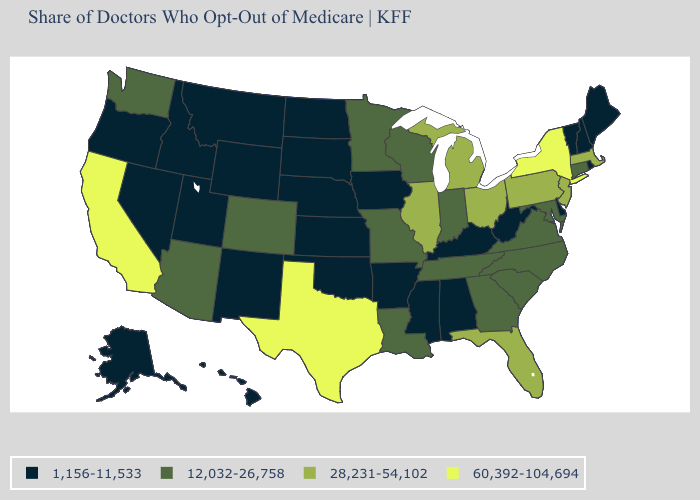Name the states that have a value in the range 28,231-54,102?
Concise answer only. Florida, Illinois, Massachusetts, Michigan, New Jersey, Ohio, Pennsylvania. Does Iowa have the lowest value in the USA?
Give a very brief answer. Yes. Which states have the lowest value in the West?
Concise answer only. Alaska, Hawaii, Idaho, Montana, Nevada, New Mexico, Oregon, Utah, Wyoming. What is the value of Oklahoma?
Keep it brief. 1,156-11,533. What is the value of Rhode Island?
Concise answer only. 1,156-11,533. Does the map have missing data?
Answer briefly. No. Does Texas have the highest value in the USA?
Keep it brief. Yes. What is the highest value in the MidWest ?
Quick response, please. 28,231-54,102. Among the states that border Idaho , does Nevada have the highest value?
Be succinct. No. Does Ohio have the lowest value in the USA?
Write a very short answer. No. Name the states that have a value in the range 28,231-54,102?
Quick response, please. Florida, Illinois, Massachusetts, Michigan, New Jersey, Ohio, Pennsylvania. Among the states that border Vermont , which have the lowest value?
Answer briefly. New Hampshire. Name the states that have a value in the range 1,156-11,533?
Give a very brief answer. Alabama, Alaska, Arkansas, Delaware, Hawaii, Idaho, Iowa, Kansas, Kentucky, Maine, Mississippi, Montana, Nebraska, Nevada, New Hampshire, New Mexico, North Dakota, Oklahoma, Oregon, Rhode Island, South Dakota, Utah, Vermont, West Virginia, Wyoming. What is the highest value in the South ?
Answer briefly. 60,392-104,694. 